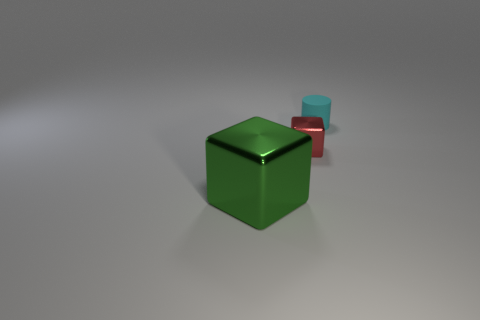Is there anything else that has the same material as the small cyan cylinder?
Offer a very short reply. No. What is the size of the other object that is the same shape as the small red shiny thing?
Ensure brevity in your answer.  Large. Is there anything else that is the same size as the green metallic block?
Provide a short and direct response. No. Do the cube left of the small metal object and the small block have the same material?
Your answer should be very brief. Yes. What is the color of the other metal object that is the same shape as the tiny red metallic object?
Make the answer very short. Green. How many other objects are the same color as the big block?
Provide a short and direct response. 0. There is a small object in front of the cyan rubber thing; is its shape the same as the object in front of the red metallic thing?
Ensure brevity in your answer.  Yes. How many spheres are either cyan things or tiny objects?
Offer a terse response. 0. Is the number of cyan rubber things that are in front of the tiny block less than the number of large red rubber cubes?
Your answer should be compact. No. What number of other things are the same material as the tiny cyan object?
Your answer should be compact. 0. 